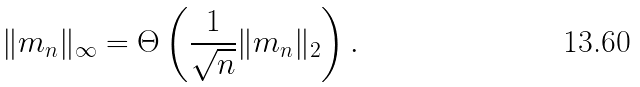Convert formula to latex. <formula><loc_0><loc_0><loc_500><loc_500>\| m _ { n } \| _ { \infty } = \Theta \left ( \frac { 1 } { \sqrt { n } } \| m _ { n } \| _ { 2 } \right ) .</formula> 